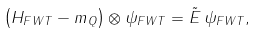<formula> <loc_0><loc_0><loc_500><loc_500>\left ( H _ { F W T } - m _ { Q } \right ) \otimes \psi _ { F W T } = \tilde { E } \, \psi _ { F W T } ,</formula> 